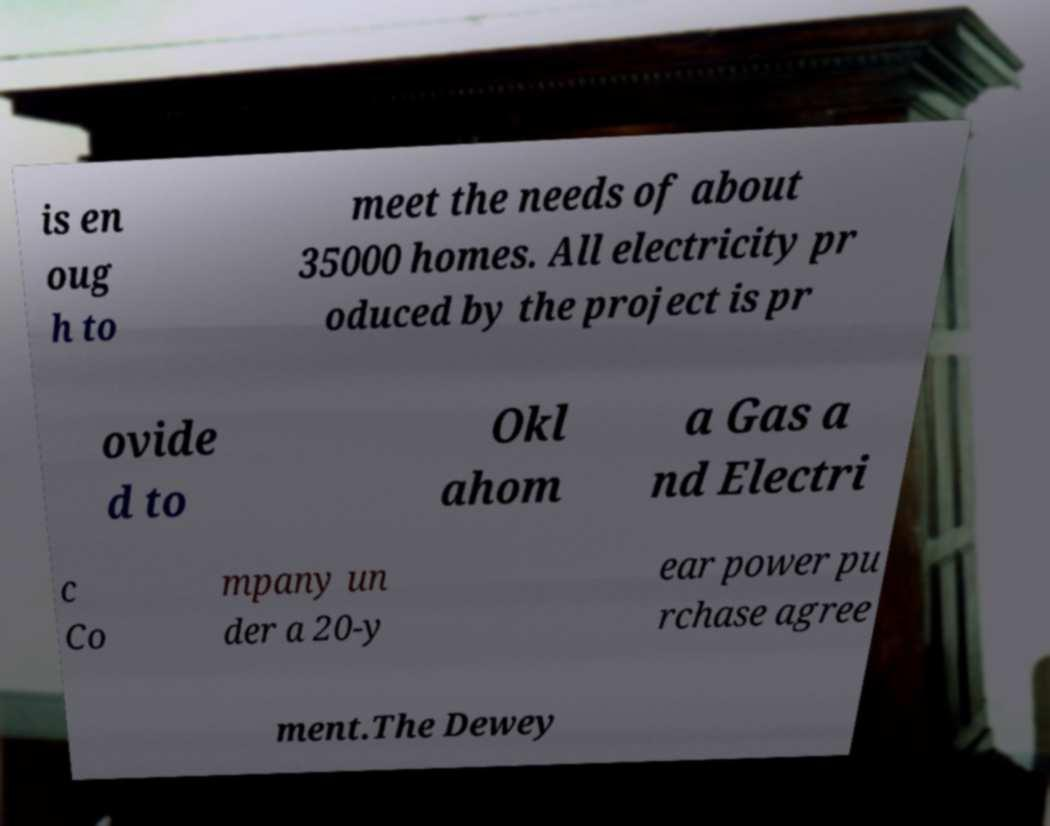Could you assist in decoding the text presented in this image and type it out clearly? is en oug h to meet the needs of about 35000 homes. All electricity pr oduced by the project is pr ovide d to Okl ahom a Gas a nd Electri c Co mpany un der a 20-y ear power pu rchase agree ment.The Dewey 